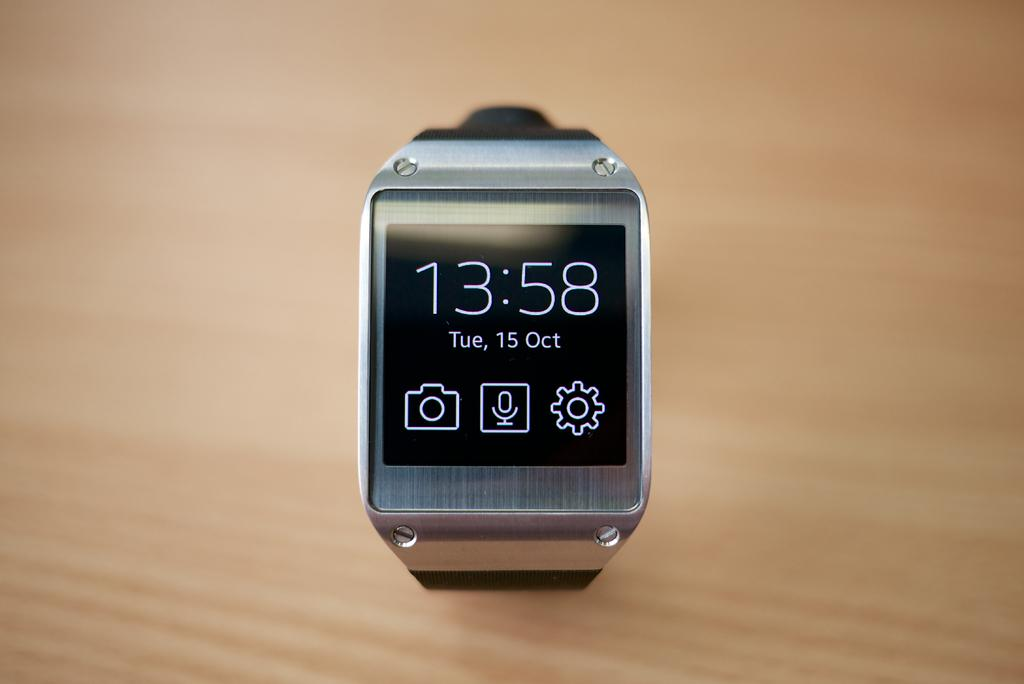<image>
Describe the image concisely. A smart watch which is showing the time as 13:58. 